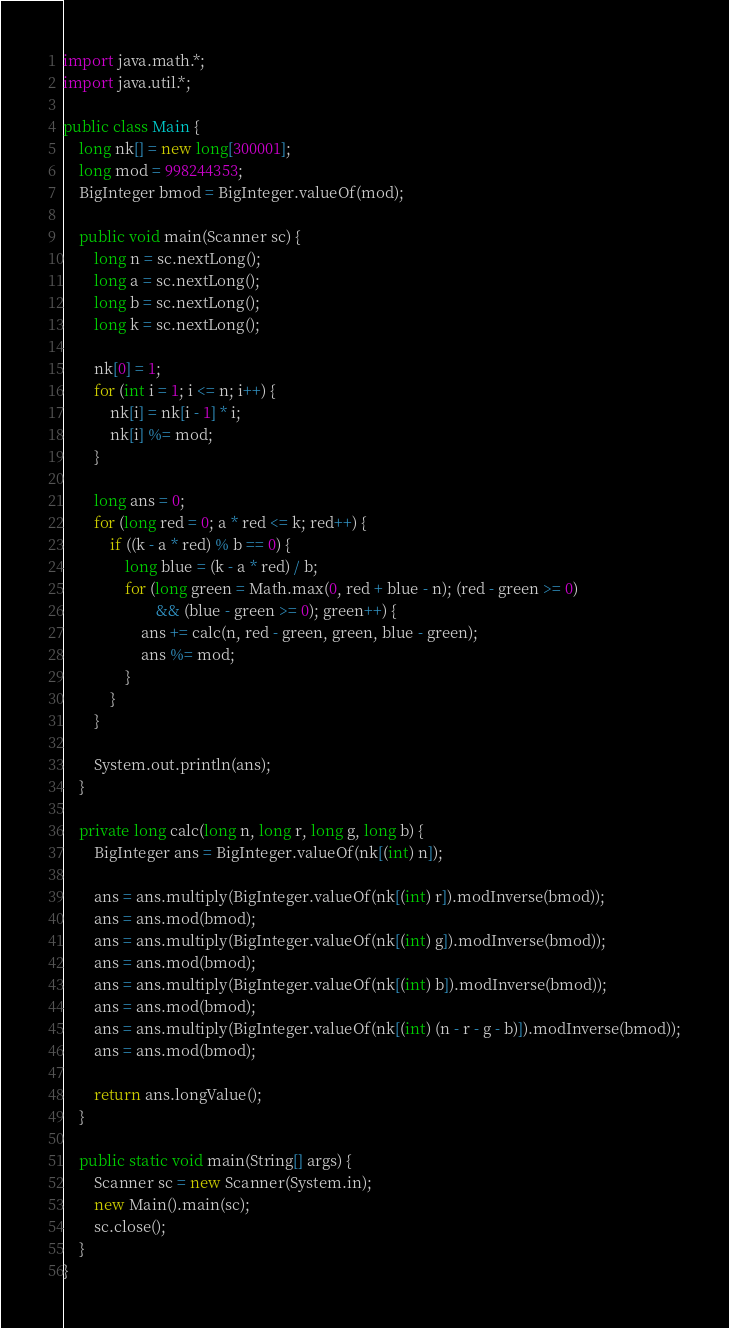Convert code to text. <code><loc_0><loc_0><loc_500><loc_500><_Java_>import java.math.*;
import java.util.*;

public class Main {
    long nk[] = new long[300001];
    long mod = 998244353;
    BigInteger bmod = BigInteger.valueOf(mod);

    public void main(Scanner sc) {
        long n = sc.nextLong();
        long a = sc.nextLong();
        long b = sc.nextLong();
        long k = sc.nextLong();

        nk[0] = 1;
        for (int i = 1; i <= n; i++) {
            nk[i] = nk[i - 1] * i;
            nk[i] %= mod;
        }

        long ans = 0;
        for (long red = 0; a * red <= k; red++) {
            if ((k - a * red) % b == 0) {
                long blue = (k - a * red) / b;
                for (long green = Math.max(0, red + blue - n); (red - green >= 0)
                        && (blue - green >= 0); green++) {
                    ans += calc(n, red - green, green, blue - green);
                    ans %= mod;
                }
            }
        }

        System.out.println(ans);
    }

    private long calc(long n, long r, long g, long b) {
        BigInteger ans = BigInteger.valueOf(nk[(int) n]);

        ans = ans.multiply(BigInteger.valueOf(nk[(int) r]).modInverse(bmod));
        ans = ans.mod(bmod);
        ans = ans.multiply(BigInteger.valueOf(nk[(int) g]).modInverse(bmod));
        ans = ans.mod(bmod);
        ans = ans.multiply(BigInteger.valueOf(nk[(int) b]).modInverse(bmod));
        ans = ans.mod(bmod);
        ans = ans.multiply(BigInteger.valueOf(nk[(int) (n - r - g - b)]).modInverse(bmod));
        ans = ans.mod(bmod);

        return ans.longValue();
    }

    public static void main(String[] args) {
        Scanner sc = new Scanner(System.in);
        new Main().main(sc);
        sc.close();
    }
}
</code> 